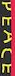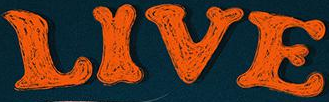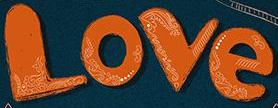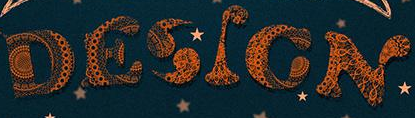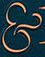Read the text from these images in sequence, separated by a semicolon. PEACE; LIVE; Love; DESIGN; & 